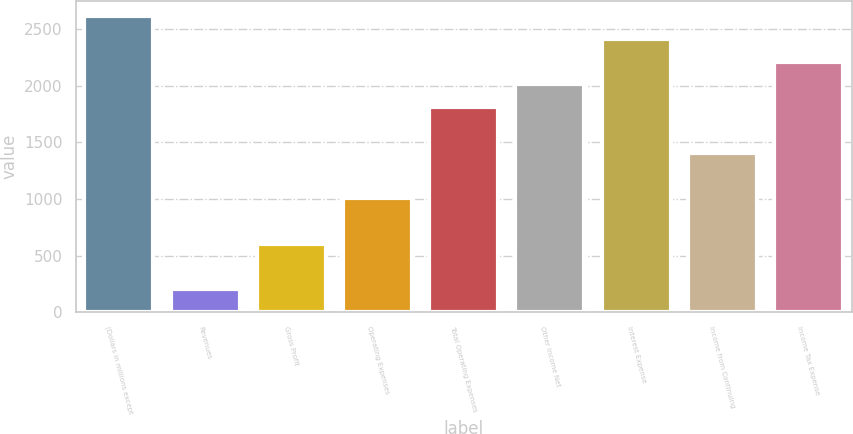<chart> <loc_0><loc_0><loc_500><loc_500><bar_chart><fcel>(Dollars in millions except<fcel>Revenues<fcel>Gross Profit<fcel>Operating Expenses<fcel>Total Operating Expenses<fcel>Other Income Net<fcel>Interest Expense<fcel>Income from Continuing<fcel>Income Tax Expense<nl><fcel>2614<fcel>202<fcel>604<fcel>1006<fcel>1810<fcel>2011<fcel>2413<fcel>1408<fcel>2212<nl></chart> 